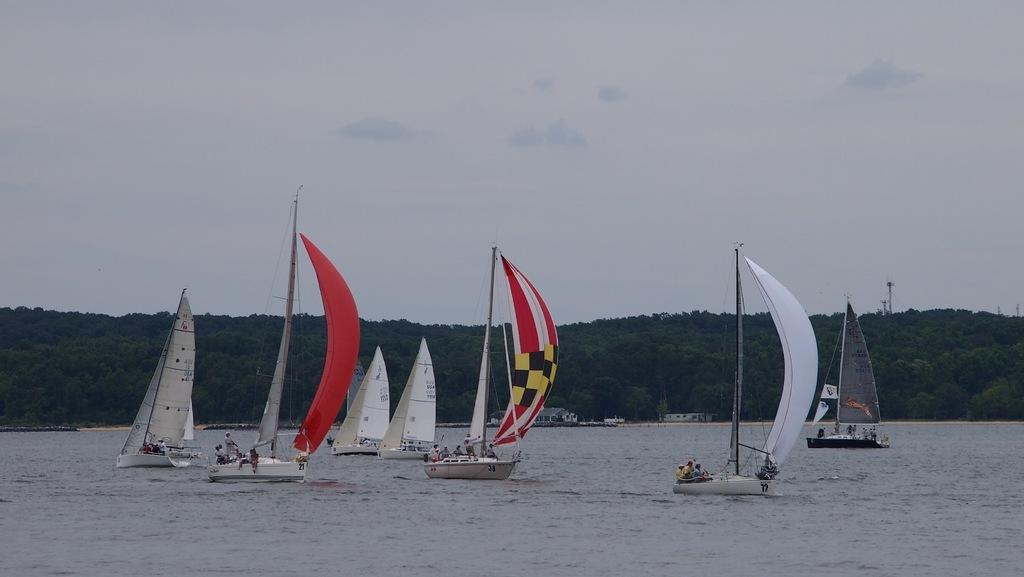What type of water body is present in the image? There is a river in the image. What is on the river in the image? There are boats on the river. What can be seen in the distance in the image? There are hills visible in the background of the image. What else is visible in the background of the image? The sky is visible in the background of the image. What type of chess piece is floating on the river in the image? There is no chess piece present in the image; it is a river with boats. What type of brush is being used to paint the hills in the background of the image? There is no brush or painting activity present in the image; it is a photograph or illustration of a river, boats, hills, and sky. 